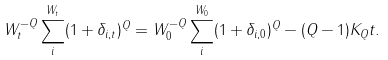Convert formula to latex. <formula><loc_0><loc_0><loc_500><loc_500>W _ { t } ^ { - Q } \sum _ { i } ^ { W _ { t } } ( 1 + \delta _ { i , t } ) ^ { Q } = W _ { 0 } ^ { - Q } \sum _ { i } ^ { W _ { 0 } } ( 1 + \delta _ { i , 0 } ) ^ { Q } - ( Q - 1 ) K _ { Q } t .</formula> 